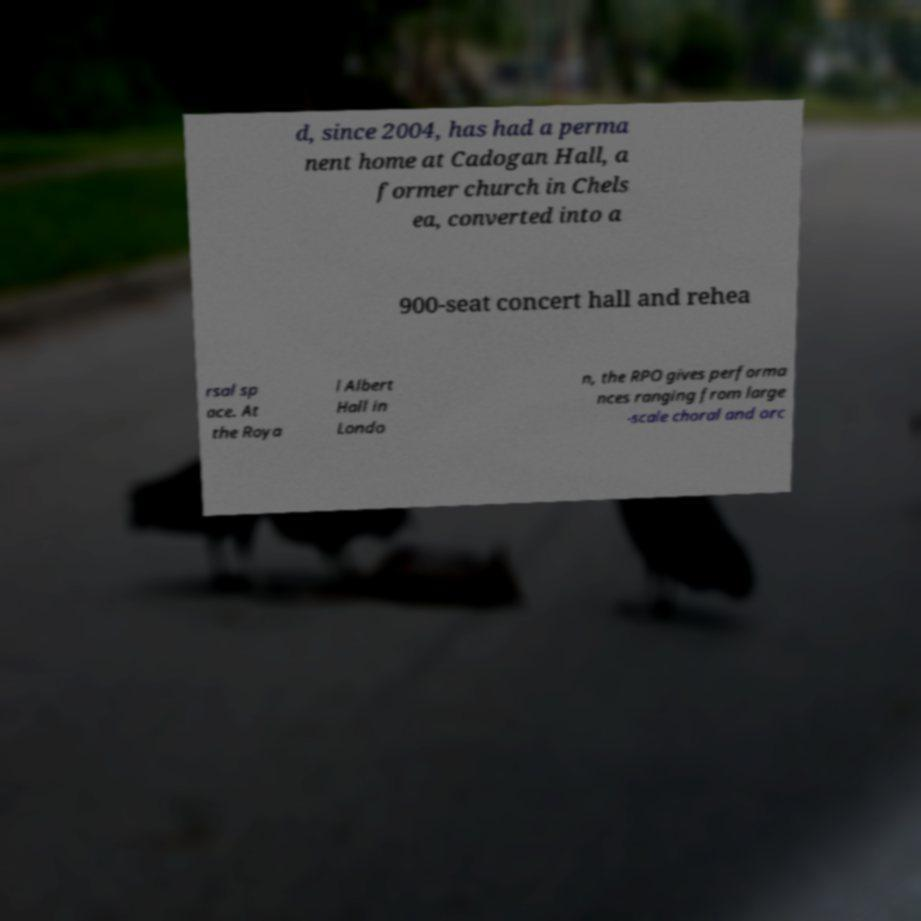What messages or text are displayed in this image? I need them in a readable, typed format. d, since 2004, has had a perma nent home at Cadogan Hall, a former church in Chels ea, converted into a 900-seat concert hall and rehea rsal sp ace. At the Roya l Albert Hall in Londo n, the RPO gives performa nces ranging from large -scale choral and orc 